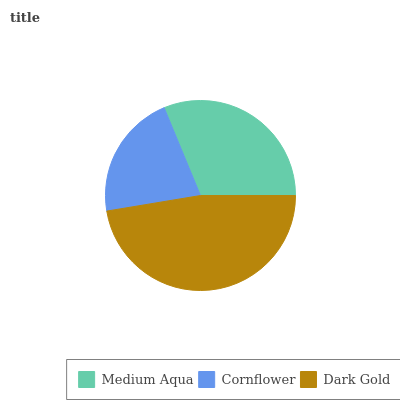Is Cornflower the minimum?
Answer yes or no. Yes. Is Dark Gold the maximum?
Answer yes or no. Yes. Is Dark Gold the minimum?
Answer yes or no. No. Is Cornflower the maximum?
Answer yes or no. No. Is Dark Gold greater than Cornflower?
Answer yes or no. Yes. Is Cornflower less than Dark Gold?
Answer yes or no. Yes. Is Cornflower greater than Dark Gold?
Answer yes or no. No. Is Dark Gold less than Cornflower?
Answer yes or no. No. Is Medium Aqua the high median?
Answer yes or no. Yes. Is Medium Aqua the low median?
Answer yes or no. Yes. Is Cornflower the high median?
Answer yes or no. No. Is Dark Gold the low median?
Answer yes or no. No. 